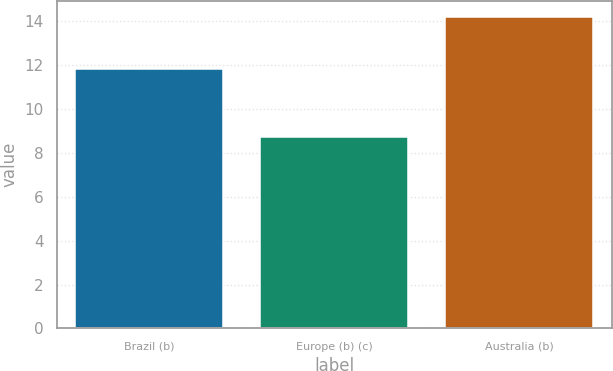Convert chart. <chart><loc_0><loc_0><loc_500><loc_500><bar_chart><fcel>Brazil (b)<fcel>Europe (b) (c)<fcel>Australia (b)<nl><fcel>11.8<fcel>8.7<fcel>14.2<nl></chart> 